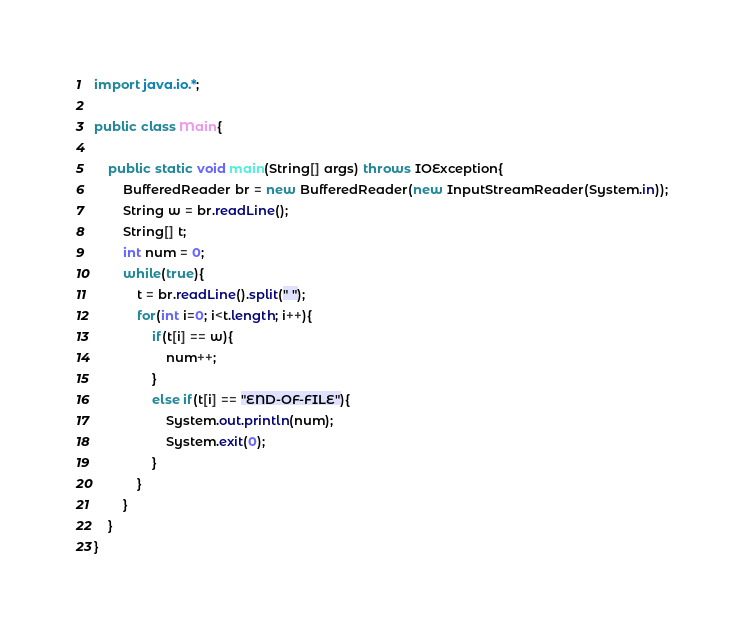<code> <loc_0><loc_0><loc_500><loc_500><_Java_>import java.io.*;

public class Main{

    public static void main(String[] args) throws IOException{
        BufferedReader br = new BufferedReader(new InputStreamReader(System.in));
        String w = br.readLine();
        String[] t;
        int num = 0;
        while(true){
            t = br.readLine().split(" ");
            for(int i=0; i<t.length; i++){
                if(t[i] == w){
                    num++;
                }
                else if(t[i] == "END-OF-FILE"){
                    System.out.println(num);
                    System.exit(0);
                }
            }
        }
    }
}</code> 